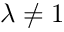<formula> <loc_0><loc_0><loc_500><loc_500>\lambda \ne 1</formula> 